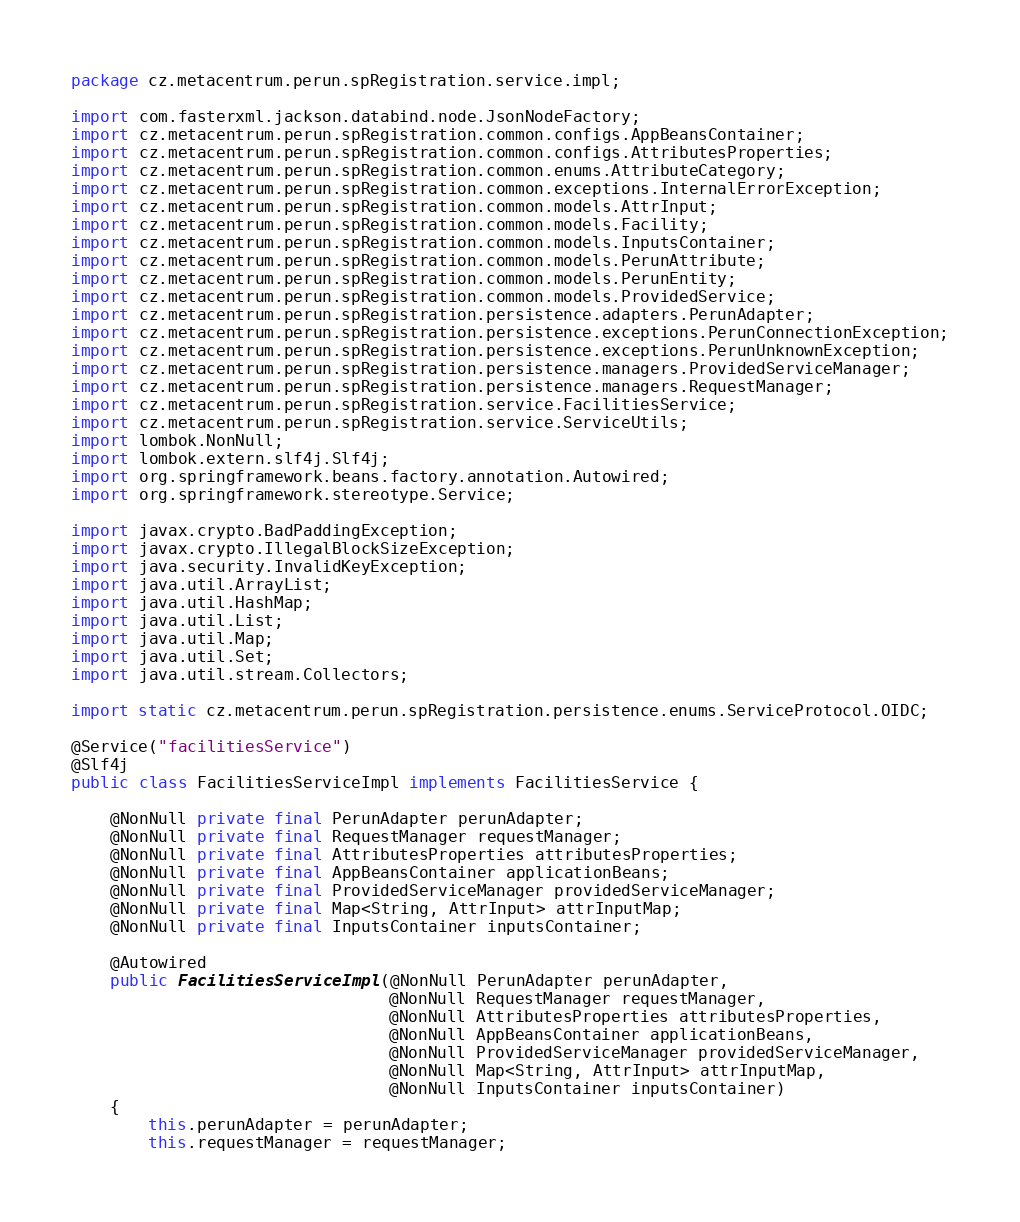Convert code to text. <code><loc_0><loc_0><loc_500><loc_500><_Java_>package cz.metacentrum.perun.spRegistration.service.impl;

import com.fasterxml.jackson.databind.node.JsonNodeFactory;
import cz.metacentrum.perun.spRegistration.common.configs.AppBeansContainer;
import cz.metacentrum.perun.spRegistration.common.configs.AttributesProperties;
import cz.metacentrum.perun.spRegistration.common.enums.AttributeCategory;
import cz.metacentrum.perun.spRegistration.common.exceptions.InternalErrorException;
import cz.metacentrum.perun.spRegistration.common.models.AttrInput;
import cz.metacentrum.perun.spRegistration.common.models.Facility;
import cz.metacentrum.perun.spRegistration.common.models.InputsContainer;
import cz.metacentrum.perun.spRegistration.common.models.PerunAttribute;
import cz.metacentrum.perun.spRegistration.common.models.PerunEntity;
import cz.metacentrum.perun.spRegistration.common.models.ProvidedService;
import cz.metacentrum.perun.spRegistration.persistence.adapters.PerunAdapter;
import cz.metacentrum.perun.spRegistration.persistence.exceptions.PerunConnectionException;
import cz.metacentrum.perun.spRegistration.persistence.exceptions.PerunUnknownException;
import cz.metacentrum.perun.spRegistration.persistence.managers.ProvidedServiceManager;
import cz.metacentrum.perun.spRegistration.persistence.managers.RequestManager;
import cz.metacentrum.perun.spRegistration.service.FacilitiesService;
import cz.metacentrum.perun.spRegistration.service.ServiceUtils;
import lombok.NonNull;
import lombok.extern.slf4j.Slf4j;
import org.springframework.beans.factory.annotation.Autowired;
import org.springframework.stereotype.Service;

import javax.crypto.BadPaddingException;
import javax.crypto.IllegalBlockSizeException;
import java.security.InvalidKeyException;
import java.util.ArrayList;
import java.util.HashMap;
import java.util.List;
import java.util.Map;
import java.util.Set;
import java.util.stream.Collectors;

import static cz.metacentrum.perun.spRegistration.persistence.enums.ServiceProtocol.OIDC;

@Service("facilitiesService")
@Slf4j
public class FacilitiesServiceImpl implements FacilitiesService {

    @NonNull private final PerunAdapter perunAdapter;
    @NonNull private final RequestManager requestManager;
    @NonNull private final AttributesProperties attributesProperties;
    @NonNull private final AppBeansContainer applicationBeans;
    @NonNull private final ProvidedServiceManager providedServiceManager;
    @NonNull private final Map<String, AttrInput> attrInputMap;
    @NonNull private final InputsContainer inputsContainer;

    @Autowired
    public FacilitiesServiceImpl(@NonNull PerunAdapter perunAdapter,
                                 @NonNull RequestManager requestManager,
                                 @NonNull AttributesProperties attributesProperties,
                                 @NonNull AppBeansContainer applicationBeans,
                                 @NonNull ProvidedServiceManager providedServiceManager,
                                 @NonNull Map<String, AttrInput> attrInputMap,
                                 @NonNull InputsContainer inputsContainer)
    {
        this.perunAdapter = perunAdapter;
        this.requestManager = requestManager;</code> 